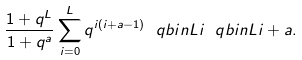Convert formula to latex. <formula><loc_0><loc_0><loc_500><loc_500>\frac { 1 + q ^ { L } } { 1 + q ^ { a } } \sum _ { i = 0 } ^ { L } q ^ { i ( i + a - 1 ) } \ q b i n { L } { i } \ q b i n { L } { i + a } .</formula> 